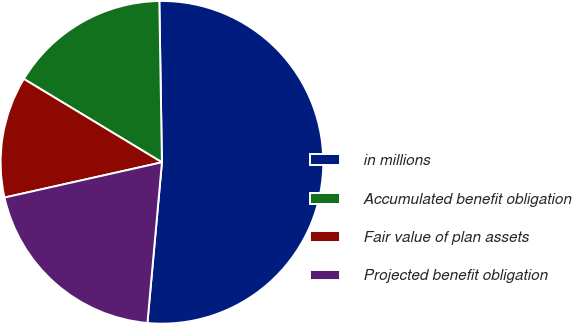Convert chart to OTSL. <chart><loc_0><loc_0><loc_500><loc_500><pie_chart><fcel>in millions<fcel>Accumulated benefit obligation<fcel>Fair value of plan assets<fcel>Projected benefit obligation<nl><fcel>51.69%<fcel>16.1%<fcel>12.15%<fcel>20.06%<nl></chart> 